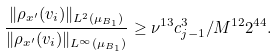Convert formula to latex. <formula><loc_0><loc_0><loc_500><loc_500>\frac { \| \rho _ { x ^ { \prime } } ( v _ { i } ) \| _ { L ^ { 2 } ( \mu _ { B _ { 1 } } ) } } { \| \rho _ { x ^ { \prime } } ( v _ { i } ) \| _ { L ^ { \infty } ( \mu _ { B _ { 1 } } ) } } \geq \nu ^ { 1 3 } c _ { j - 1 } ^ { 3 } / M ^ { 1 2 } 2 ^ { 4 4 } .</formula> 